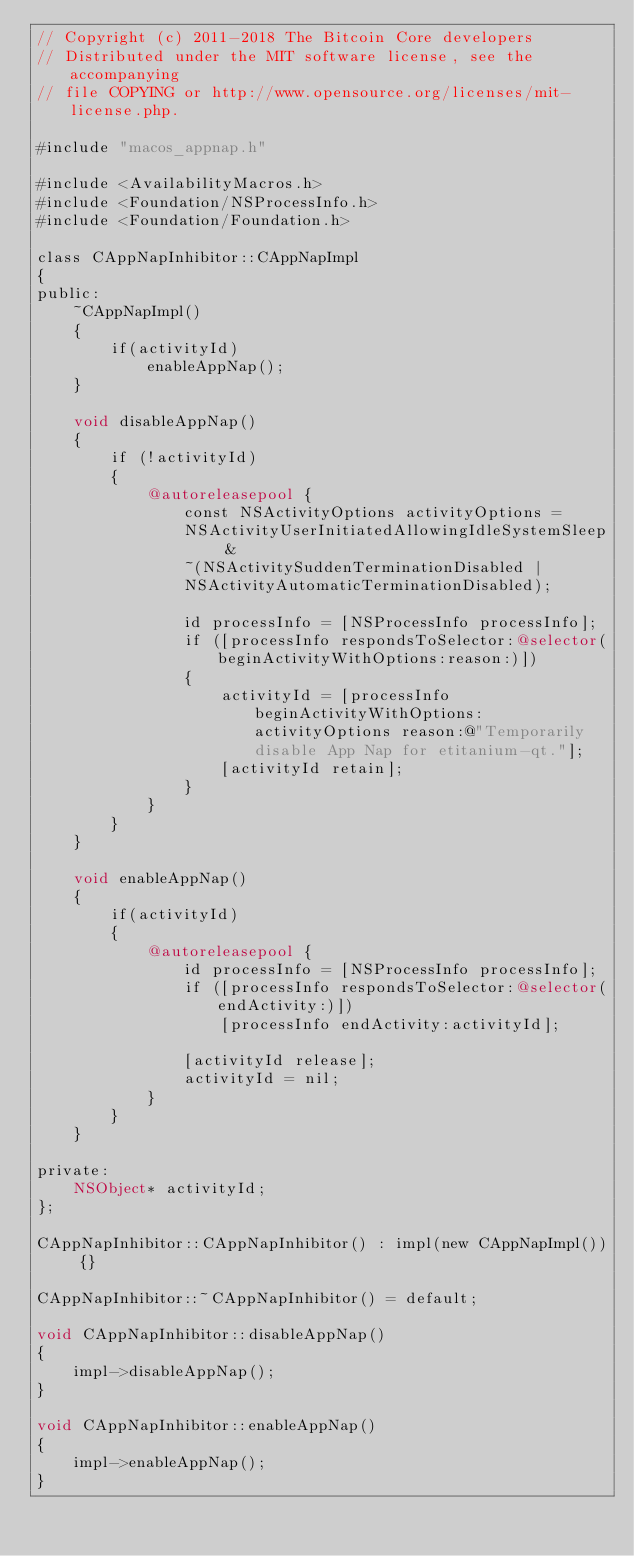<code> <loc_0><loc_0><loc_500><loc_500><_ObjectiveC_>// Copyright (c) 2011-2018 The Bitcoin Core developers
// Distributed under the MIT software license, see the accompanying
// file COPYING or http://www.opensource.org/licenses/mit-license.php.

#include "macos_appnap.h"

#include <AvailabilityMacros.h>
#include <Foundation/NSProcessInfo.h>
#include <Foundation/Foundation.h>

class CAppNapInhibitor::CAppNapImpl
{
public:
    ~CAppNapImpl()
    {
        if(activityId)
            enableAppNap();
    }

    void disableAppNap()
    {
        if (!activityId)
        {
            @autoreleasepool {
                const NSActivityOptions activityOptions =
                NSActivityUserInitiatedAllowingIdleSystemSleep &
                ~(NSActivitySuddenTerminationDisabled |
                NSActivityAutomaticTerminationDisabled);

                id processInfo = [NSProcessInfo processInfo];
                if ([processInfo respondsToSelector:@selector(beginActivityWithOptions:reason:)])
                {
                    activityId = [processInfo beginActivityWithOptions: activityOptions reason:@"Temporarily disable App Nap for etitanium-qt."];
                    [activityId retain];
                }
            }
        }
    }

    void enableAppNap()
    {
        if(activityId)
        {
            @autoreleasepool {
                id processInfo = [NSProcessInfo processInfo];
                if ([processInfo respondsToSelector:@selector(endActivity:)])
                    [processInfo endActivity:activityId];

                [activityId release];
                activityId = nil;
            }
        }
    }

private:
    NSObject* activityId;
};

CAppNapInhibitor::CAppNapInhibitor() : impl(new CAppNapImpl()) {}

CAppNapInhibitor::~CAppNapInhibitor() = default;

void CAppNapInhibitor::disableAppNap()
{
    impl->disableAppNap();
}

void CAppNapInhibitor::enableAppNap()
{
    impl->enableAppNap();
}
</code> 